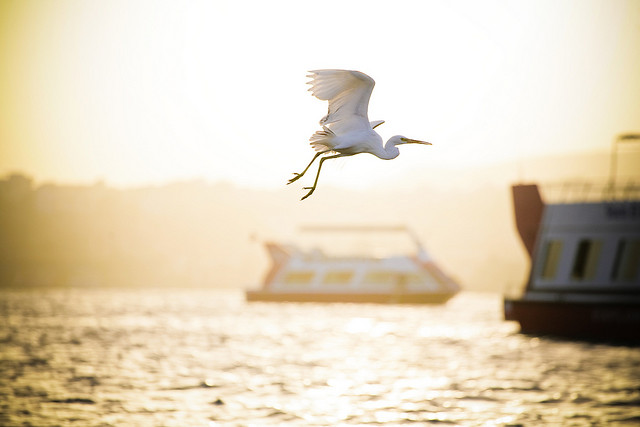Please provide the bounding box coordinate of the region this sentence describes: boat on right. The bounding box coordinates for the 'boat on right' are [0.78, 0.37, 1.0, 0.72]. 